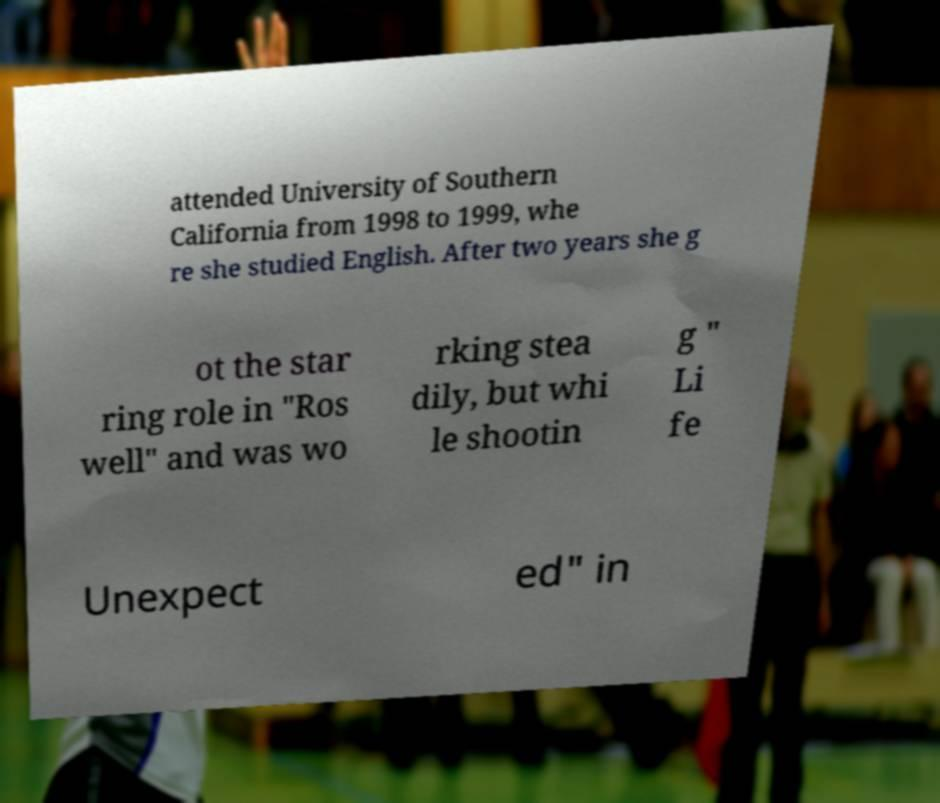What messages or text are displayed in this image? I need them in a readable, typed format. attended University of Southern California from 1998 to 1999, whe re she studied English. After two years she g ot the star ring role in "Ros well" and was wo rking stea dily, but whi le shootin g " Li fe Unexpect ed" in 